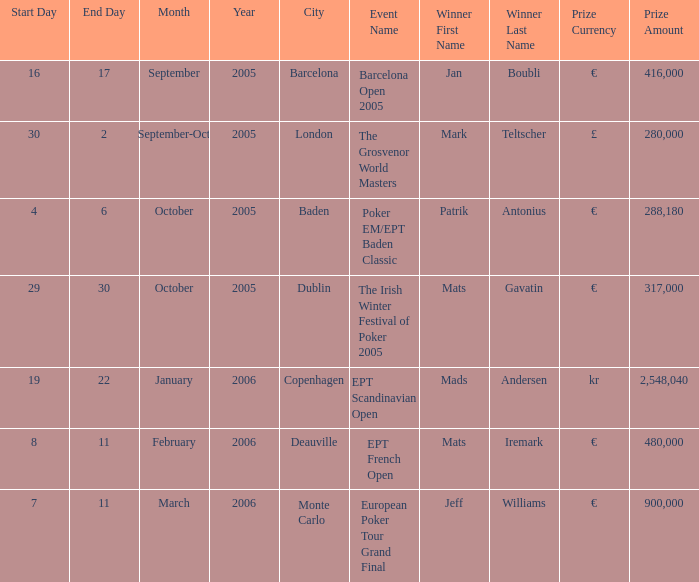In which city did patrik antonius achieve victory? Baden. 